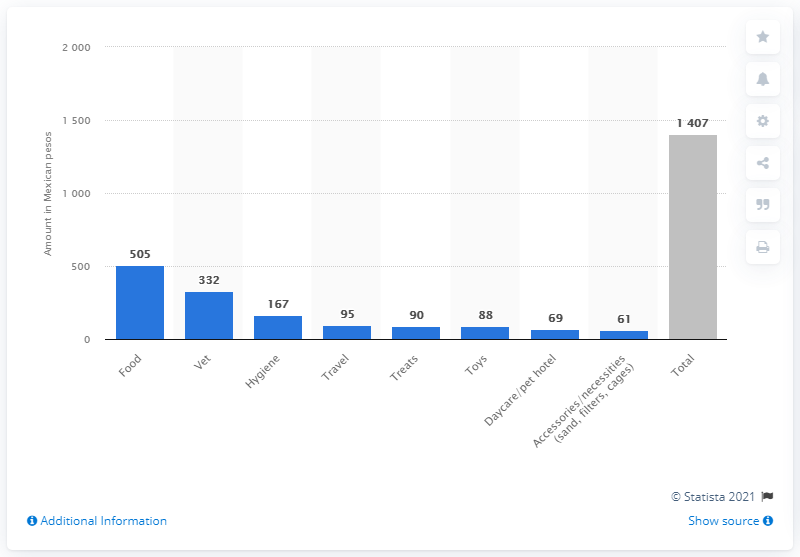Outline some significant characteristics in this image. Pet owners spent an average of 505 pesos per month on pet food in the survey. 